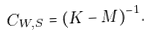<formula> <loc_0><loc_0><loc_500><loc_500>C _ { W , S } = ( K - M ) ^ { - 1 } .</formula> 